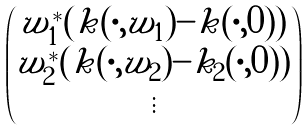Convert formula to latex. <formula><loc_0><loc_0><loc_500><loc_500>\begin{pmatrix} w _ { 1 } ^ { * } ( k ( \cdot , w _ { 1 } ) - k ( \cdot , 0 ) ) \\ w _ { 2 } ^ { * } ( k ( \cdot , w _ { 2 } ) - k _ { 2 } ( \cdot , 0 ) ) \\ \vdots \end{pmatrix}</formula> 